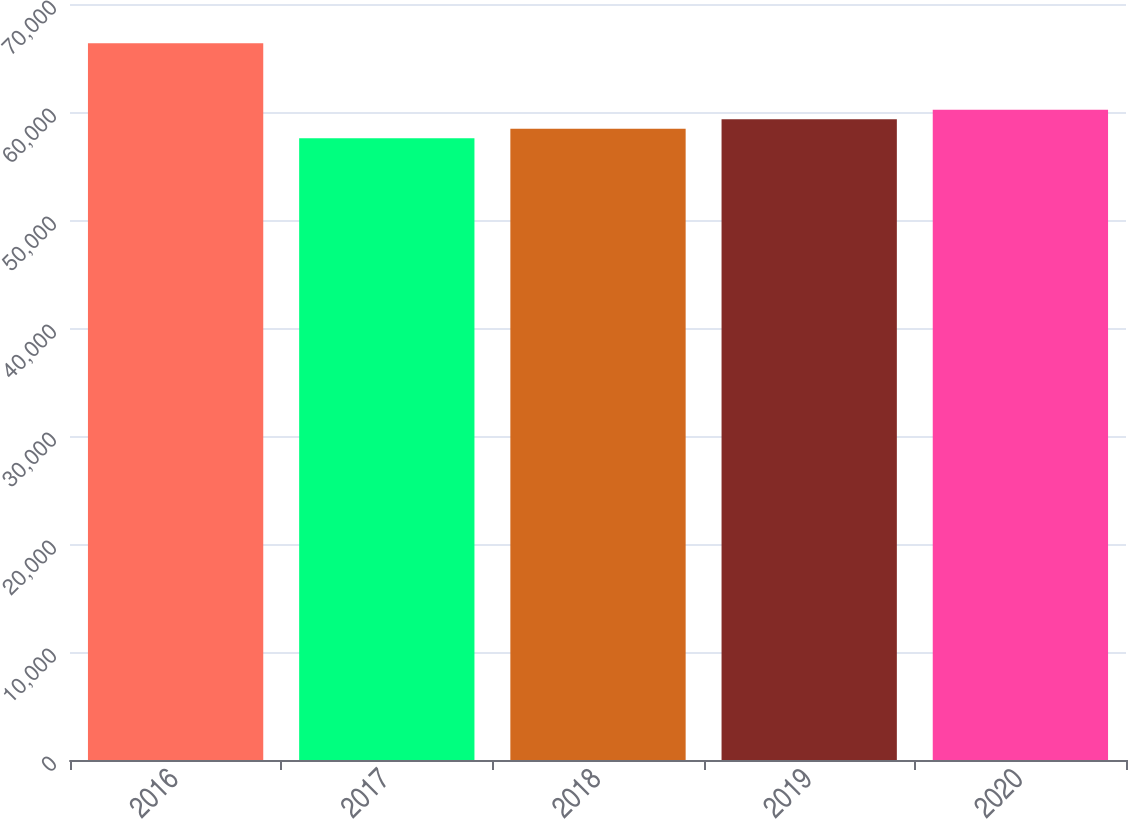<chart> <loc_0><loc_0><loc_500><loc_500><bar_chart><fcel>2016<fcel>2017<fcel>2018<fcel>2019<fcel>2020<nl><fcel>66355<fcel>57562<fcel>58441.3<fcel>59320.6<fcel>60199.9<nl></chart> 